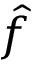Convert formula to latex. <formula><loc_0><loc_0><loc_500><loc_500>\hat { f }</formula> 